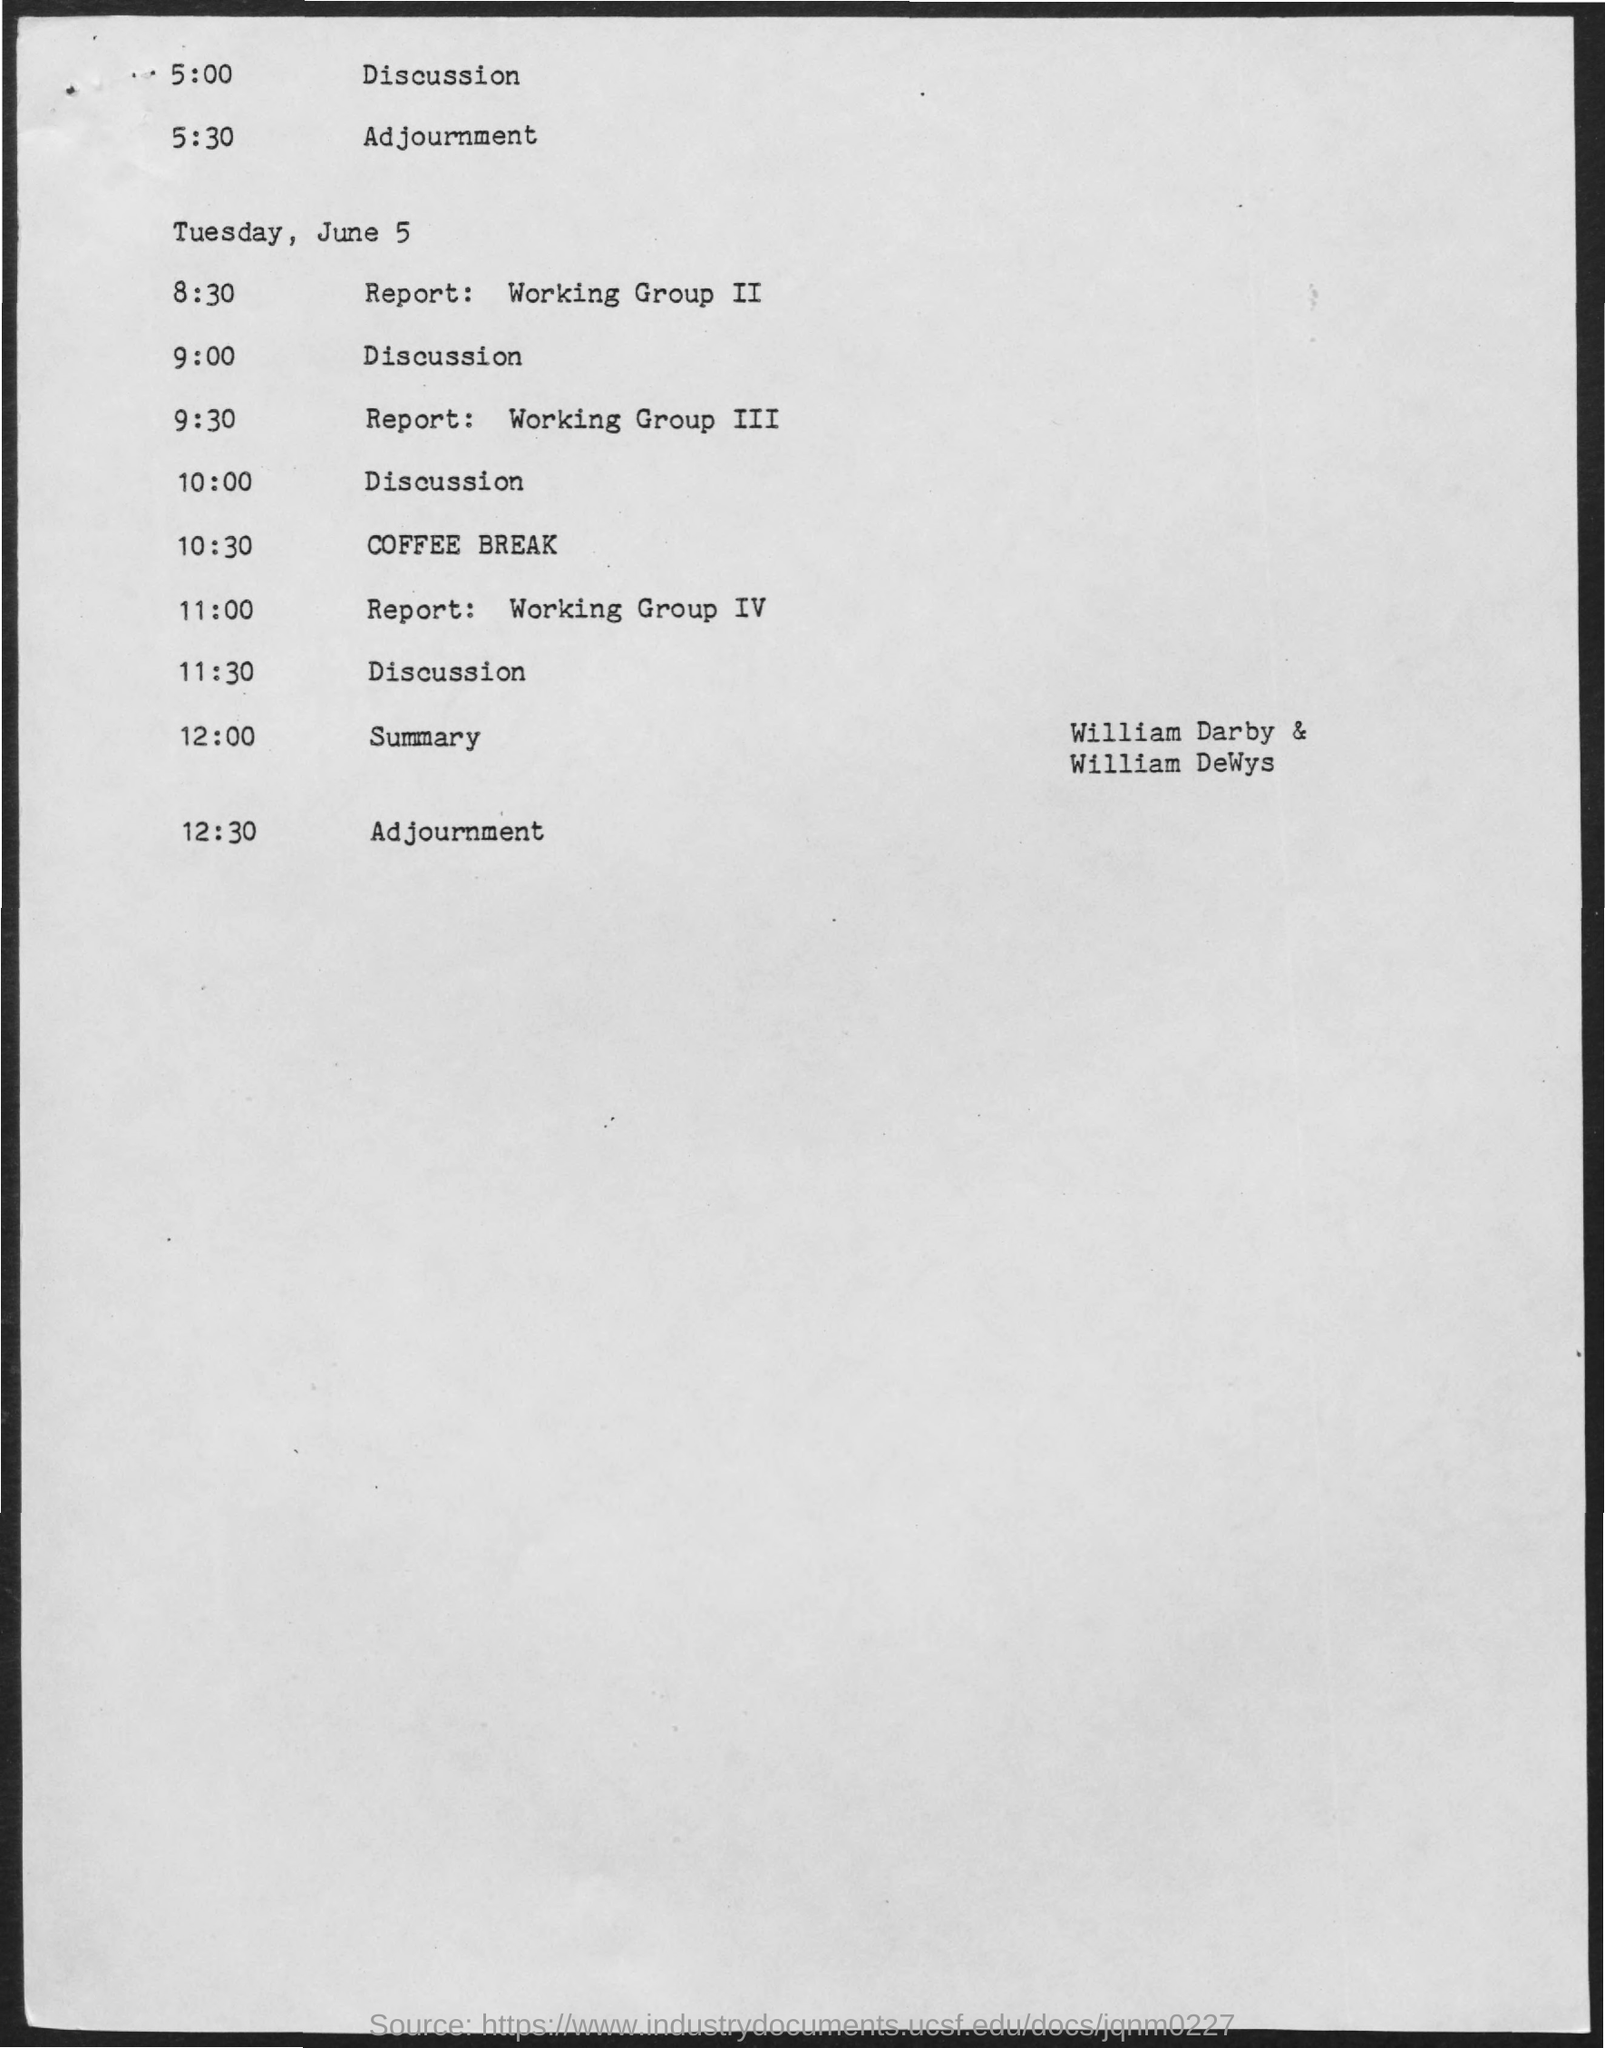Coffee Break is on which time?
Keep it short and to the point. 10:30. 